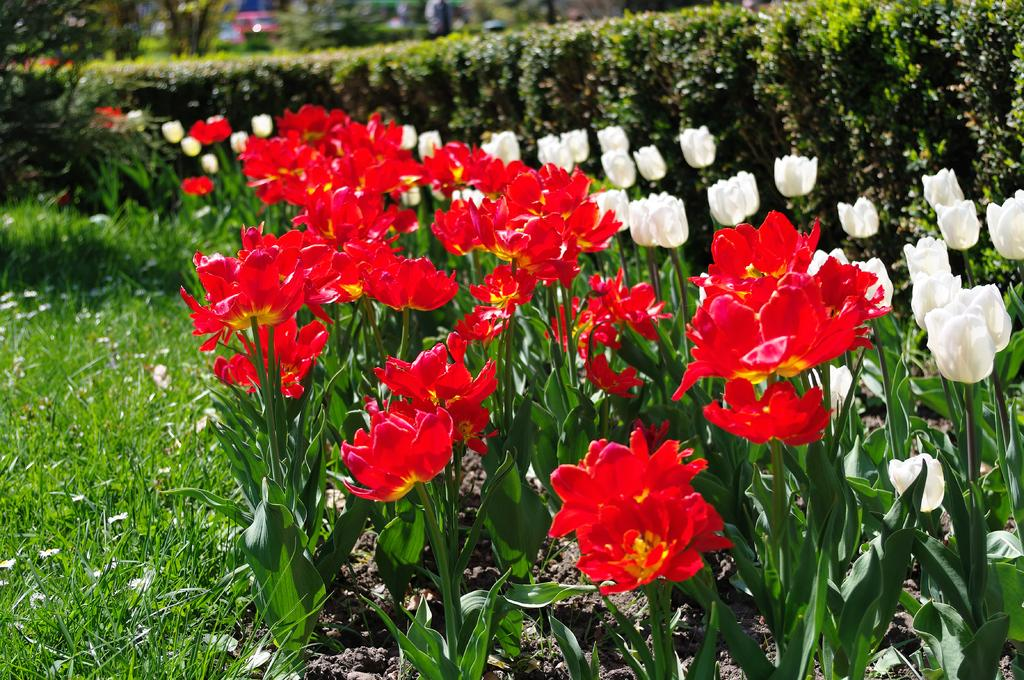What type of vegetation is present on the ground in the image? There are plants and hedges on the ground in the image. What type of grass is visible on the left side of the image? There is grass on the ground to the left in the image. What additional features can be observed about the plants in the image? There are flowers associated with the plants in the image, and specifically, there are tulips in the image. What type of station can be seen in the image? There is no station present in the image; it features plants, hedges, grass, and flowers. How do the tulips twist in the image? The tulips do not twist in the image; they are stationary and upright. 